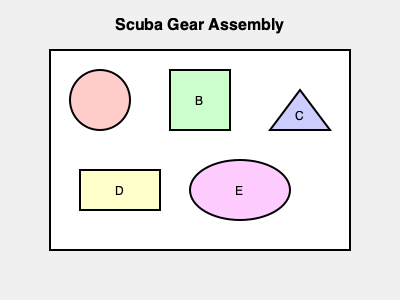As a tourism official promoting diving tourism, you need to understand the basic components of scuba gear. Based on the diagram, which sequence represents the correct order of assembly for a typical scuba setup, starting from the diver's back and moving outward? To answer this question, we need to consider the typical assembly of scuba gear and match it with the components shown in the diagram:

1. The first component attached to the diver's back is usually the air tank. In the diagram, this is represented by the rectangle labeled D.

2. Next, the buoyancy compensator (BC) or BCD (buoyancy control device) is attached to the tank. This is typically a vest-like component, represented by the ellipse labeled E.

3. The regulator is then connected to the tank. The first stage of the regulator is often a circular component, shown as the circle labeled A.

4. The second stage of the regulator, which the diver breathes from, is usually a rectangular shape. This matches the square labeled B.

5. Finally, additional accessories like a dive computer or pressure gauge are added. The triangle labeled C could represent such an accessory.

Therefore, the correct sequence of assembly, starting from the diver's back and moving outward, would be: D (tank), E (BCD), A (first stage regulator), B (second stage regulator), C (accessories).
Answer: D-E-A-B-C 